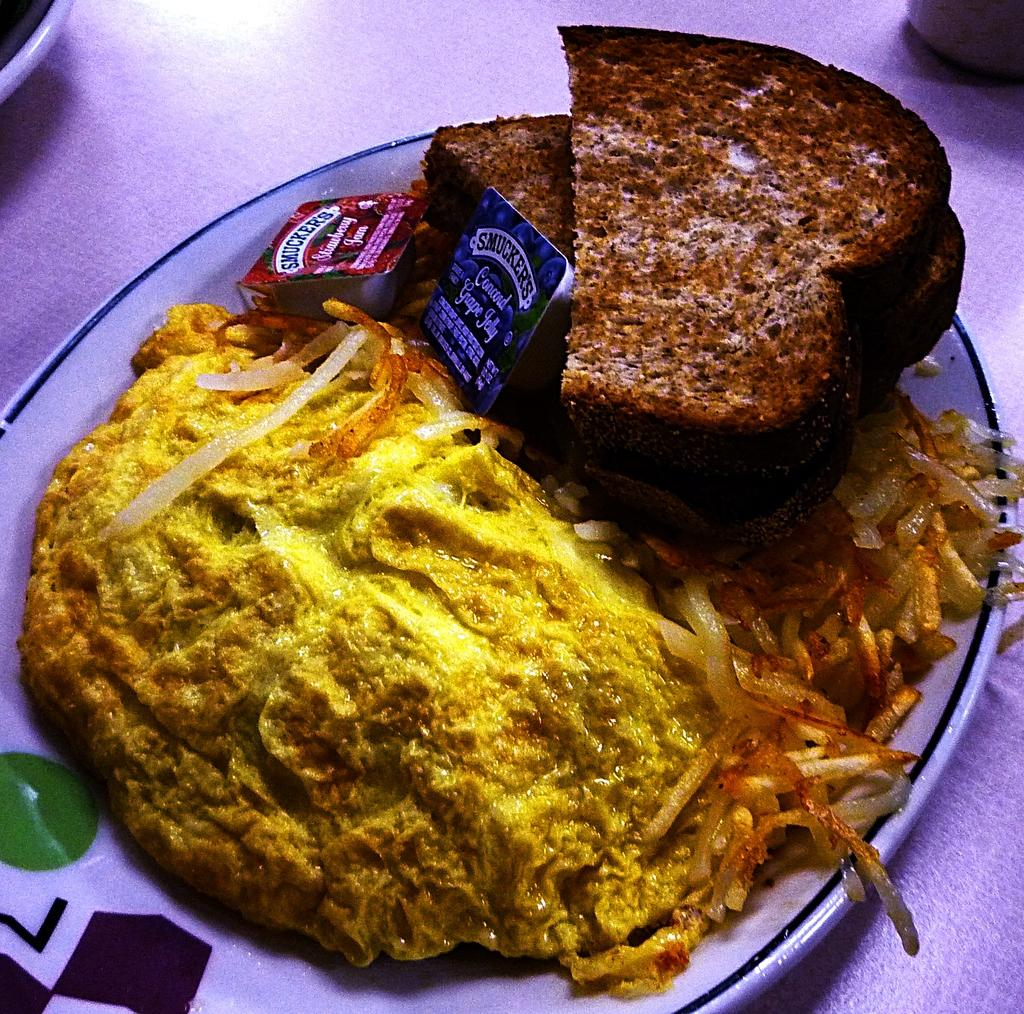What is on the plate that is visible in the image? There is food on a plate in the image. What else can be seen on the table in the image? There is a cloth on the table in the image. Can you hear the airplane flying in the image? There is no airplane present in the image, and therefore no sound can be heard. What type of blade is being used to cut the food in the image? There is no blade visible in the image, and no food is being cut. 